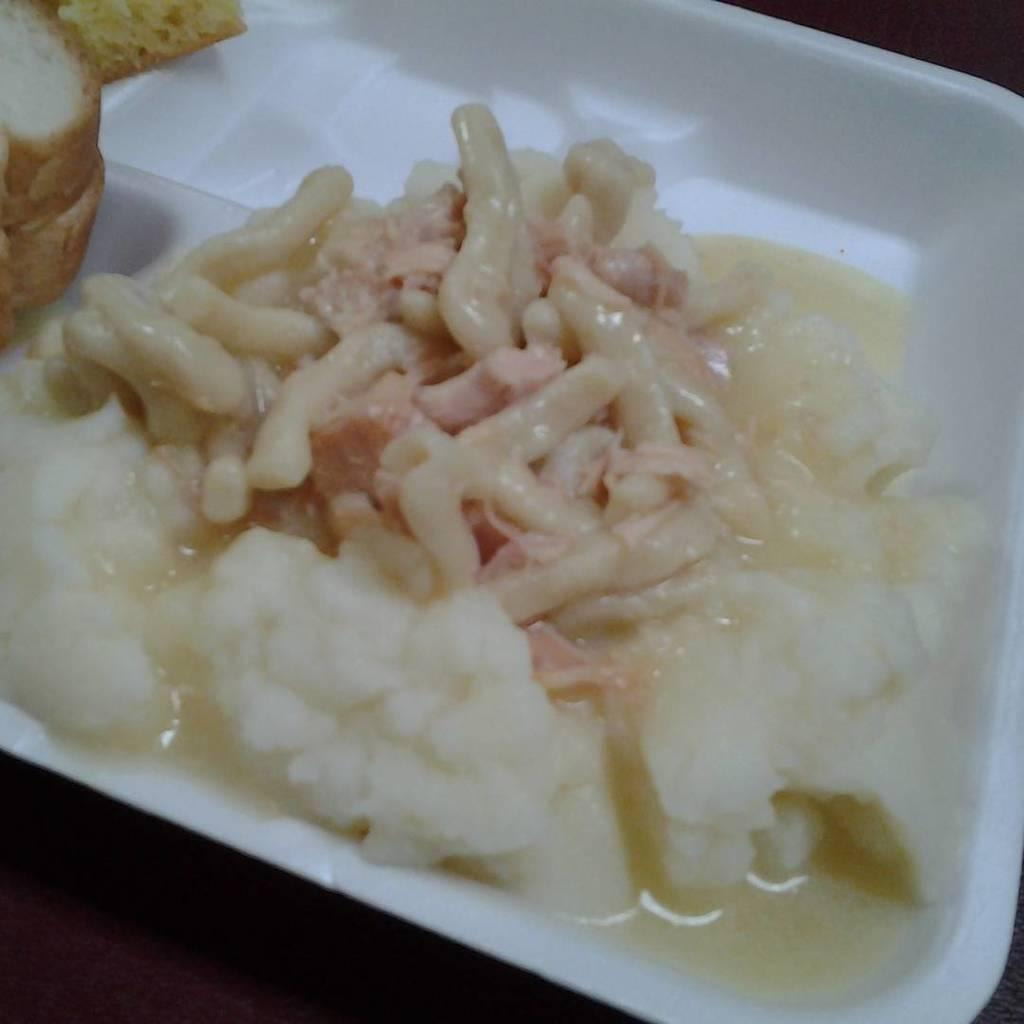What type of food item is present in the image? There is a food item in the image, but the specific type is not mentioned. How is the food item contained in the image? The food item is in a white container. What other food item can be seen in the image? There is bread in the image. What type of punishment is being depicted in the image? There is no indication of punishment in the image; it features a food item in a white container and bread. What type of pickle is being served in the image? There is no pickle present in the image. 